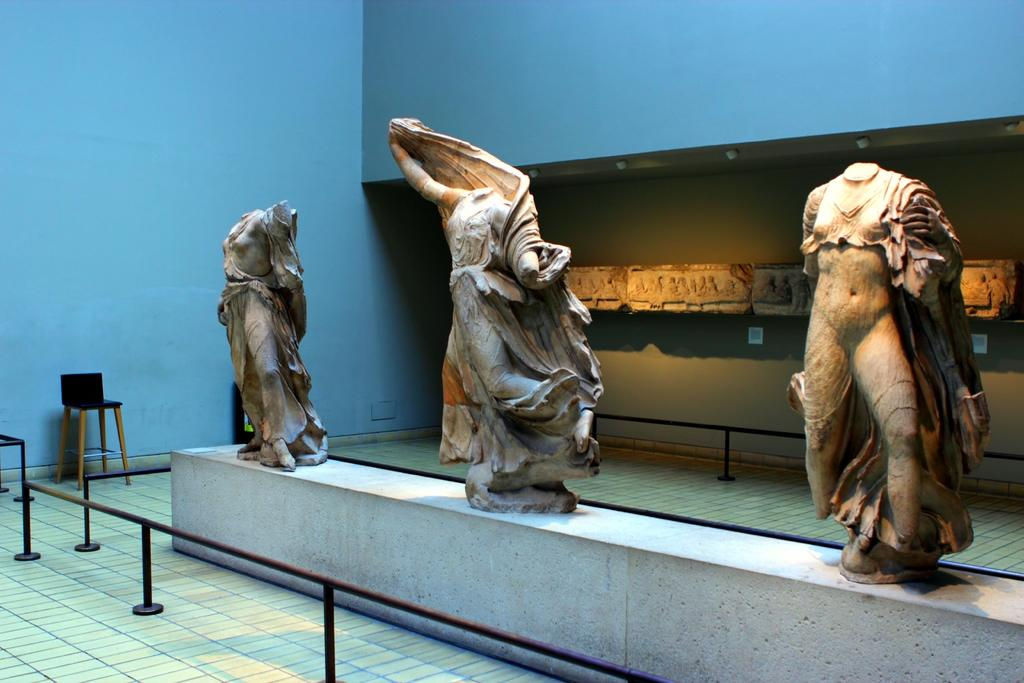What type of art is present in the image? There are sculptures in the image. What can be seen near the sculptures? There is railing in the image. What is visible in the background of the image? There is a wall and a chair in the background of the image. What type of parcel is being delivered to the sculptures in the image? There is no parcel present in the image; it only features sculptures, railing, a wall, and a chair. Can you describe the yak that is interacting with the sculptures in the image? There is no yak present in the image; it only features sculptures, railing, a wall, and a chair. 